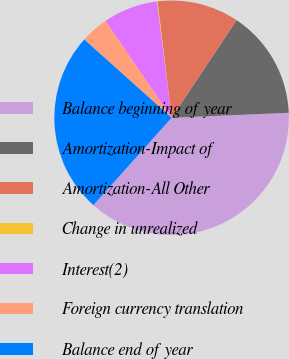Convert chart. <chart><loc_0><loc_0><loc_500><loc_500><pie_chart><fcel>Balance beginning of year<fcel>Amortization-Impact of<fcel>Amortization-All Other<fcel>Change in unrealized<fcel>Interest(2)<fcel>Foreign currency translation<fcel>Balance end of year<nl><fcel>37.29%<fcel>14.98%<fcel>11.26%<fcel>0.1%<fcel>7.54%<fcel>3.82%<fcel>25.01%<nl></chart> 